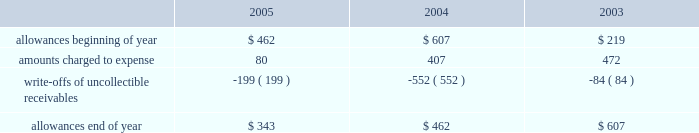Goodwill is reviewed annually during the fourth quarter for impairment .
In addition , the company performs an impairment analysis of other intangible assets based on the occurrence of other factors .
Such factors include , but are not limited to , signifi- cant changes in membership , state funding , medical contracts and provider networks and contracts .
An impairment loss is rec- ognized if the carrying value of intangible assets exceeds the implied fair value .
The company did not recognize any impair- ment losses for the periods presented .
Medical claims liabilities medical services costs include claims paid , claims reported but not yet paid ( inventory ) , estimates for claims incurred but not yet received ( ibnr ) and estimates for the costs necessary to process unpaid claims .
The estimates of medical claims liabilities are developed using standard actuarial methods based upon historical data for payment patterns , cost trends , product mix , seasonality , utiliza- tion of healthcare services and other relevant factors including product changes .
These estimates are continually reviewed and adjustments , if necessary , are reflected in the period known .
Management did not change actuarial methods during the years presented .
Management believes the amount of medical claims payable is reasonable and adequate to cover the company 2019s liabil- ity for unpaid claims as of december 31 , 2005 ; however , actual claim payments may differ from established estimates .
Revenue recognition the majority of the company 2019s medicaid managed care premi- um revenue is received monthly based on fixed rates per member as determined by state contracts .
Some contracts allow for addi- tional premium related to certain supplemental services provided such as maternity deliveries .
Revenue is recognized as earned over the covered period of services .
Revenues are recorded based on membership and eligibility data provided by the states , which may be adjusted by the states for updates to this membership and eligibility data .
These adjustments are immaterial in relation to total revenue recorded and are reflected in the period known .
Premiums collected in advance are recorded as unearned revenue .
The specialty services segment generates revenue under con- tracts with state and local government entities , our health plans and third-party customers .
Revenues for services are recognized when the services are provided or as ratably earned over the cov- ered period of services .
For performance-based contracts , the company does not recognize revenue subject to refund until data is sufficient to measure performance .
Such amounts are recorded as unearned revenue .
Revenues due to the company are recorded as premium and related receivables and recorded net of an allowance for uncol- lectible accounts based on historical trends and management 2019s judgment on the collectibility of these accounts .
Activity in the allowance for uncollectible accounts for the years ended december 31 is summarized below: .
Significant customers centene receives the majority of its revenues under contracts or subcontracts with state medicaid managed care programs .
The contracts , which expire on various dates between june 30 , 2006 and august 31 , 2008 , are expected to be renewed .
Contracts with the states of indiana , kansas , texas and wisconsin each accounted for 18% ( 18 % ) , 12% ( 12 % ) , 22% ( 22 % ) and 23% ( 23 % ) , respectively , of the company 2019s revenues for the year ended december 31 , 2005 .
Reinsurance centene has purchased reinsurance from third parties to cover eligible healthcare services .
The current reinsurance program covers 90% ( 90 % ) of inpatient healthcare expenses in excess of annual deductibles of $ 300 per member , up to a lifetime maximum of $ 2000 .
Centene 2019s medicaid managed care subsidiaries are respon- sible for inpatient charges in excess of an average daily per diem .
Reinsurance recoveries were $ 4014 , $ 3730 , and $ 5345 , in 2005 , 2004 , and 2003 , respectively .
Reinsurance expenses were approximately $ 4105 , $ 6724 , and $ 6185 in 2005 , 2004 , and 2003 , respectively .
Reinsurance recoveries , net of expenses , are included in medical costs .
Other income ( expense ) other income ( expense ) consists principally of investment income and interest expense .
Investment income is derived from the company 2019s cash , cash equivalents , restricted deposits and investments .
Interest expense relates to borrowings under our credit facility , mortgage interest , interest on capital leases and credit facility fees .
Income taxes deferred tax assets and liabilities are recorded for the future tax consequences attributable to differences between the financial statement carrying amounts of existing assets and liabilities and their respective tax bases .
Deferred tax assets and liabilities are measured using enacted tax rates expected to apply to taxable income in the years in which those temporary differences are expected to be recovered or settled .
The effect on deferred tax assets and liabilities of a change in tax rates is recognized in income in the period that includes the enactment date of the tax rate change .
Valuation allowances are provided when it is considered more likely than not that deferred tax assets will not be realized .
In determining if a deductible temporary difference or net operating loss can be realized , the company considers future reversals of .
What was the average 3 year balance in allowance for doubtful accounts , in millions? 
Computations: (((343 + 462) + 607) / 3)
Answer: 470.66667. 